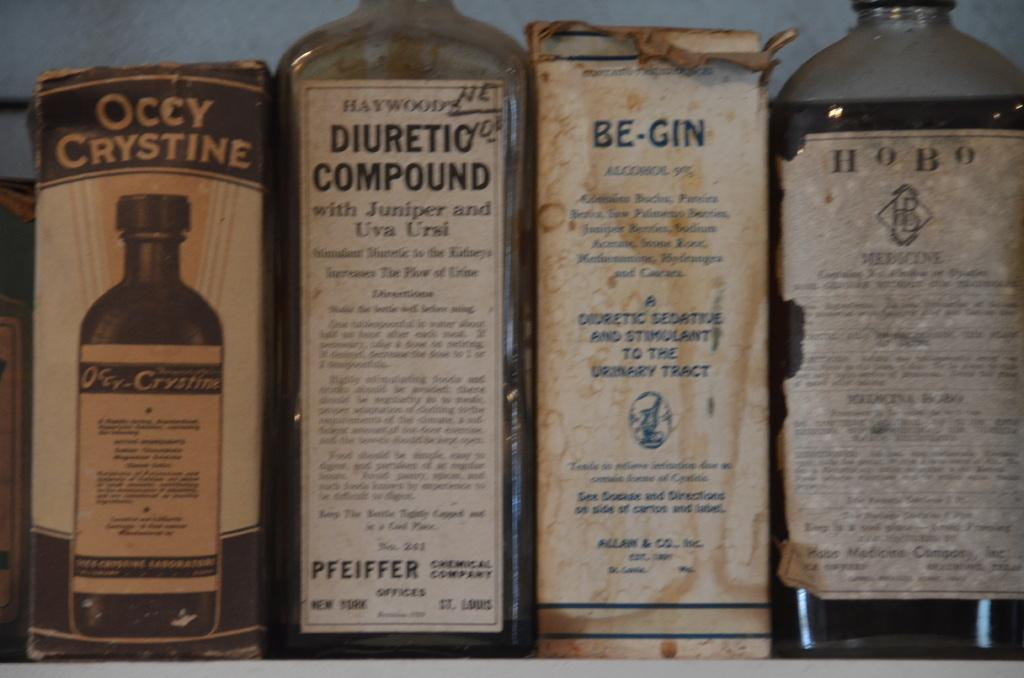Provide a one-sentence caption for the provided image. An array of old bottles and boxes with the labels Occy Crystine, Diuretic Compound, Be-Gin, and Hobo on the packages. 